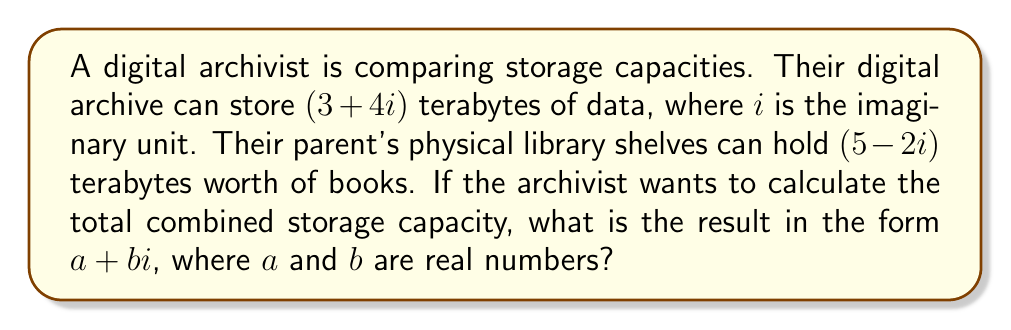Solve this math problem. To solve this problem, we need to add two complex numbers:

1) Digital archive capacity: $(3+4i)$ terabytes
2) Physical library capacity: $(5-2i)$ terabytes

To add complex numbers, we add the real and imaginary parts separately:

$$(3+4i) + (5-2i) = (3+5) + (4-2)i$$

Simplifying:

$$(3+5) + (4-2)i = 8 + 2i$$

Therefore, the total combined storage capacity is $8+2i$ terabytes.

This result shows that:
- The real part (8) represents 8 terabytes of "real" storage capacity.
- The imaginary part (2i) represents a conceptual 2 terabytes of "imaginary" storage, which could be interpreted as potential or theoretical capacity.
Answer: $8+2i$ terabytes 